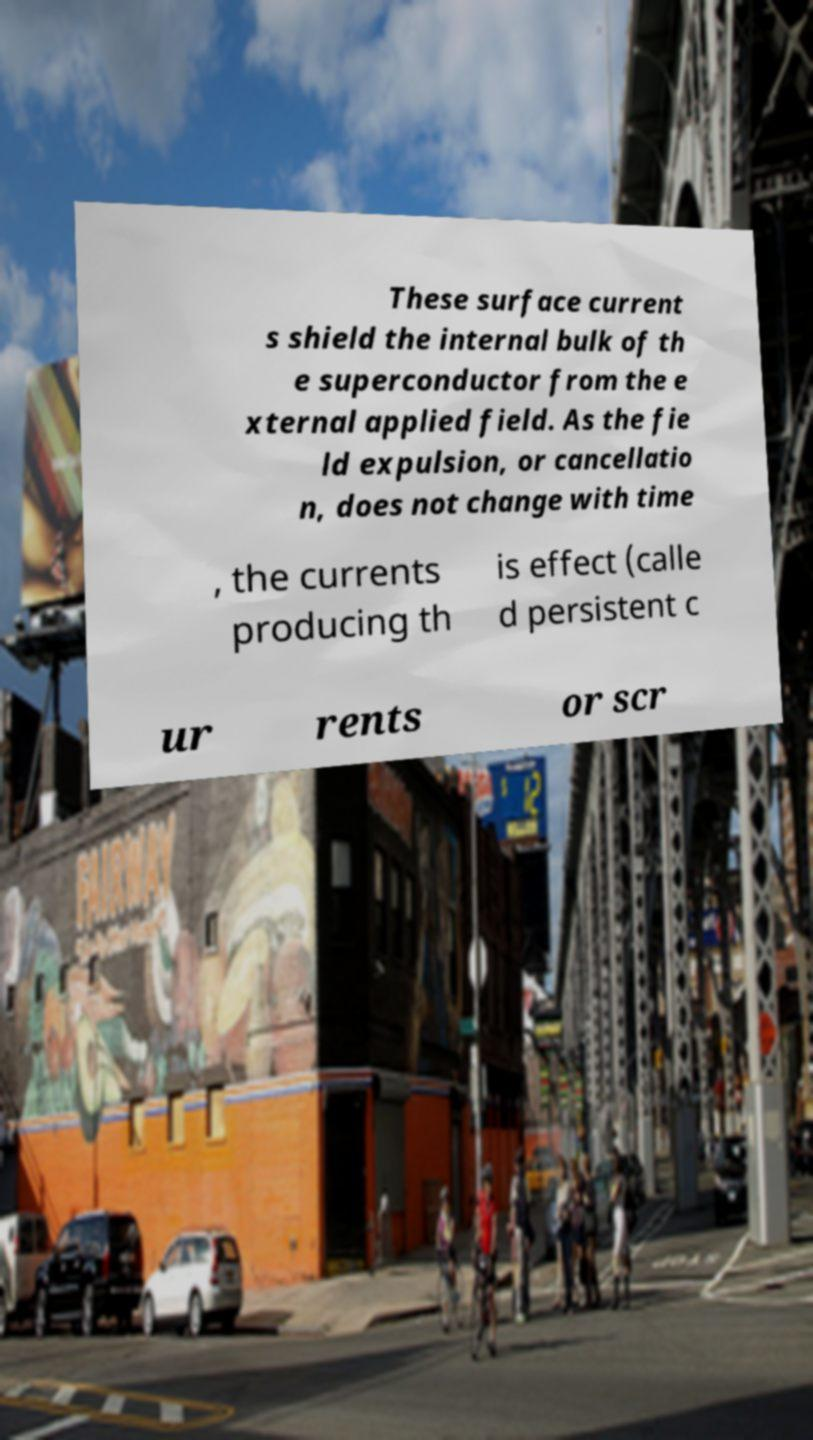Can you accurately transcribe the text from the provided image for me? These surface current s shield the internal bulk of th e superconductor from the e xternal applied field. As the fie ld expulsion, or cancellatio n, does not change with time , the currents producing th is effect (calle d persistent c ur rents or scr 